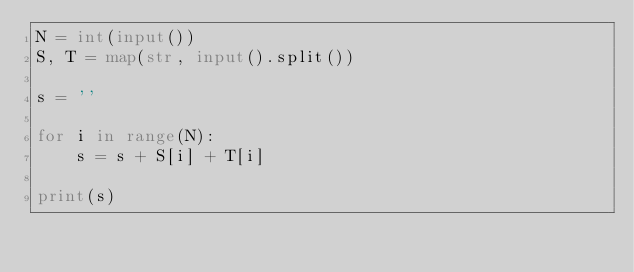<code> <loc_0><loc_0><loc_500><loc_500><_Python_>N = int(input())
S, T = map(str, input().split())

s = ''

for i in range(N):
    s = s + S[i] + T[i]

print(s)</code> 